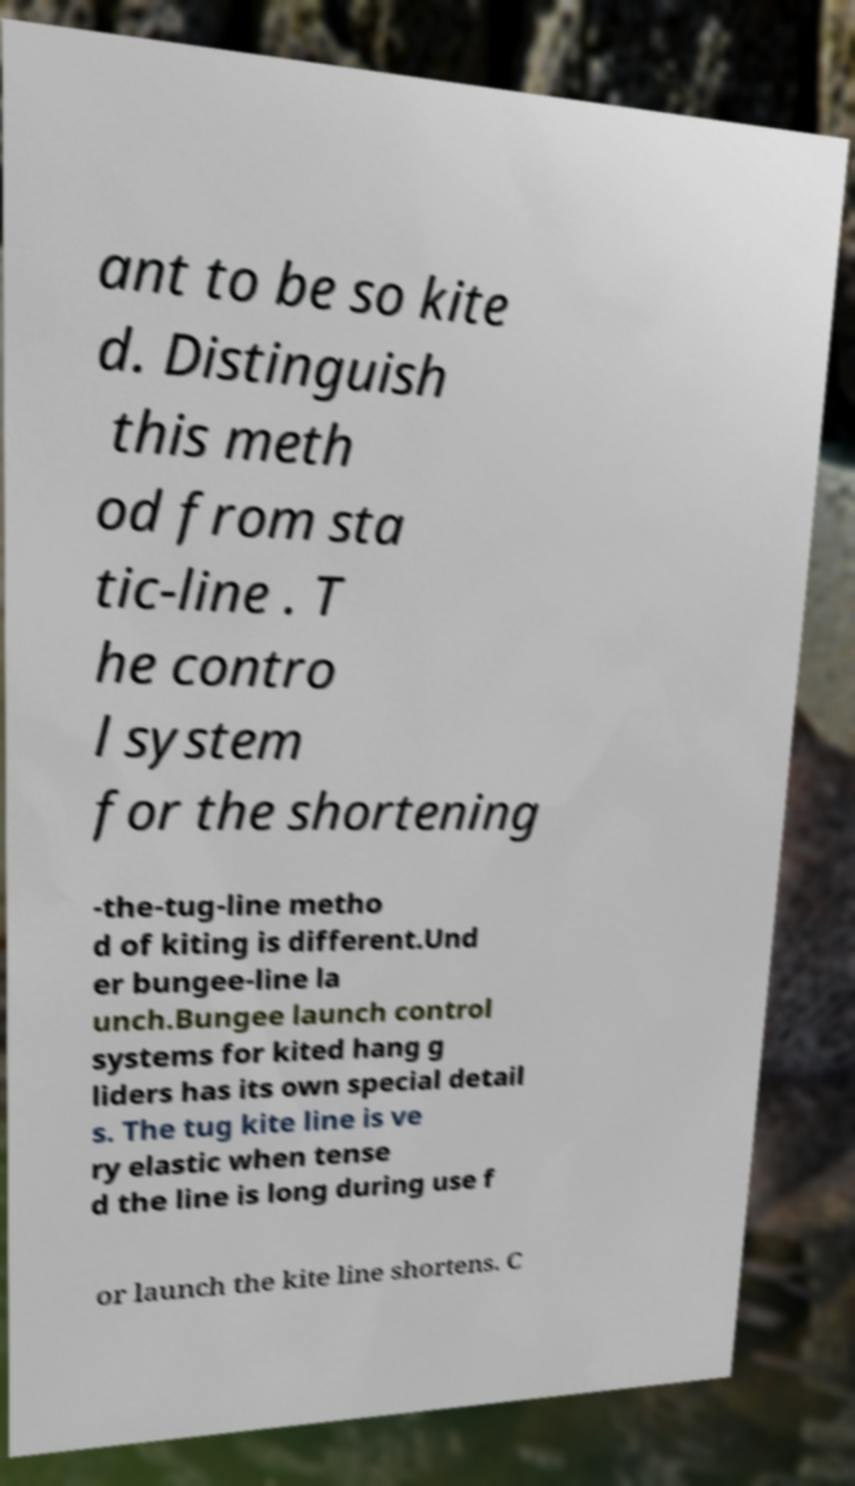Please read and relay the text visible in this image. What does it say? ant to be so kite d. Distinguish this meth od from sta tic-line . T he contro l system for the shortening -the-tug-line metho d of kiting is different.Und er bungee-line la unch.Bungee launch control systems for kited hang g liders has its own special detail s. The tug kite line is ve ry elastic when tense d the line is long during use f or launch the kite line shortens. C 